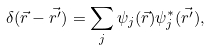<formula> <loc_0><loc_0><loc_500><loc_500>\delta ( \vec { r } - \vec { r ^ { \prime } } ) = \sum _ { j } \psi _ { j } ( \vec { r } ) \psi _ { j } ^ { * } ( \vec { r ^ { \prime } } ) ,</formula> 